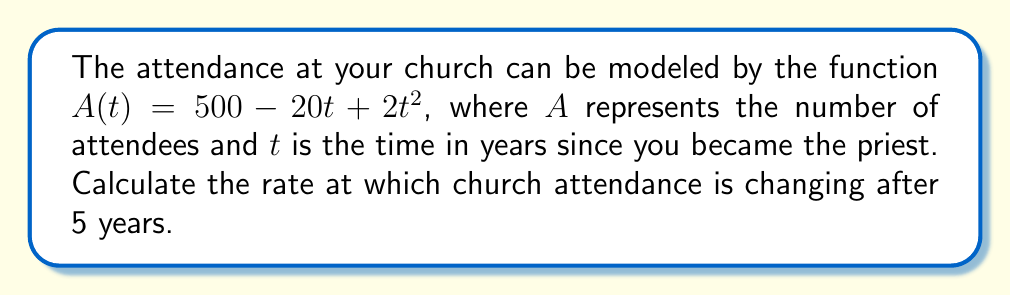Can you answer this question? To find the rate of change in church attendance after 5 years, we need to follow these steps:

1) The rate of change is given by the derivative of the attendance function $A(t)$.

2) Let's find the derivative $A'(t)$:
   $$A'(t) = \frac{d}{dt}(500 - 20t + 2t^2)$$
   $$A'(t) = 0 - 20 + 4t$$
   $$A'(t) = 4t - 20$$

3) Now that we have the derivative, we can calculate the rate of change at any given time by plugging in the value of $t$.

4) We want to know the rate of change after 5 years, so let's substitute $t = 5$:
   $$A'(5) = 4(5) - 20$$
   $$A'(5) = 20 - 20 = 0$$

5) The result of 0 means that after 5 years, the rate of change in church attendance is 0 people per year.

This indicates that at the 5-year mark, the church attendance has reached a turning point - it's neither increasing nor decreasing at this exact moment.
Answer: 0 people per year 